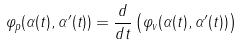Convert formula to latex. <formula><loc_0><loc_0><loc_500><loc_500>\varphi _ { p } ( \alpha ( t ) , \alpha ^ { \prime } ( t ) ) = \frac { d } { d t } \left ( \varphi _ { v } ( \alpha ( t ) , \alpha ^ { \prime } ( t ) ) \right )</formula> 